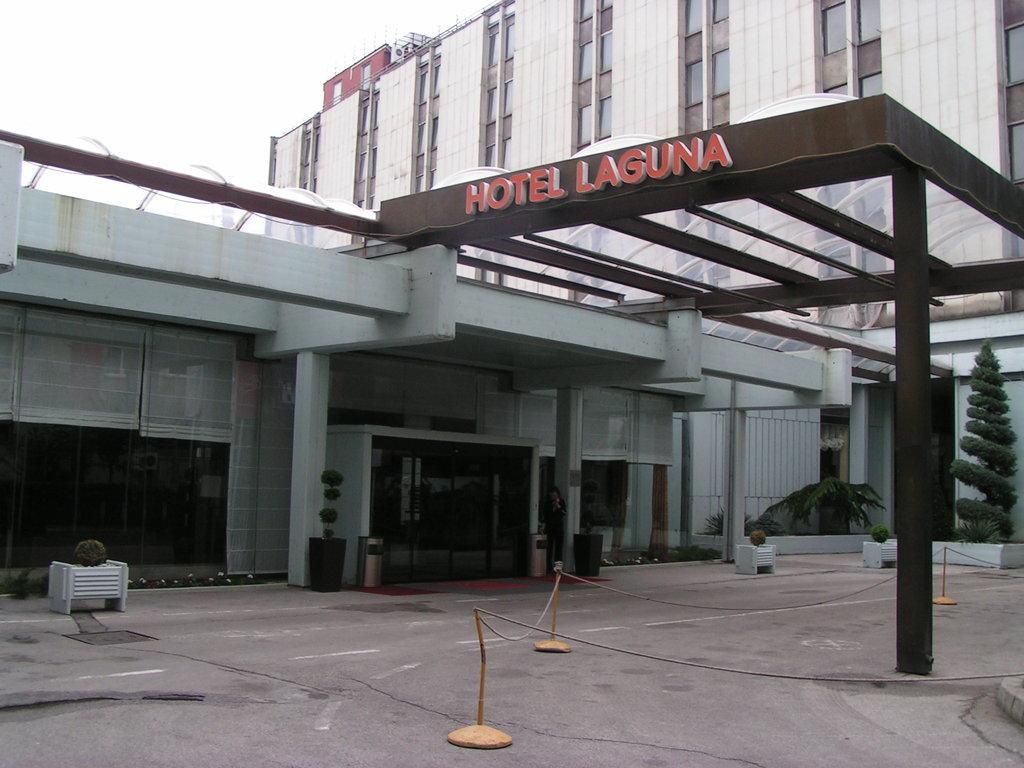How would you summarize this image in a sentence or two? In this image there is a building in the middle. In the middle there is an entrance. Beside the entrance there are flower pots and dustbins on either side of the entrance. At the top there is some text on the wall. At the bottom there is a fence. On the right side there is a tree beside the building. 